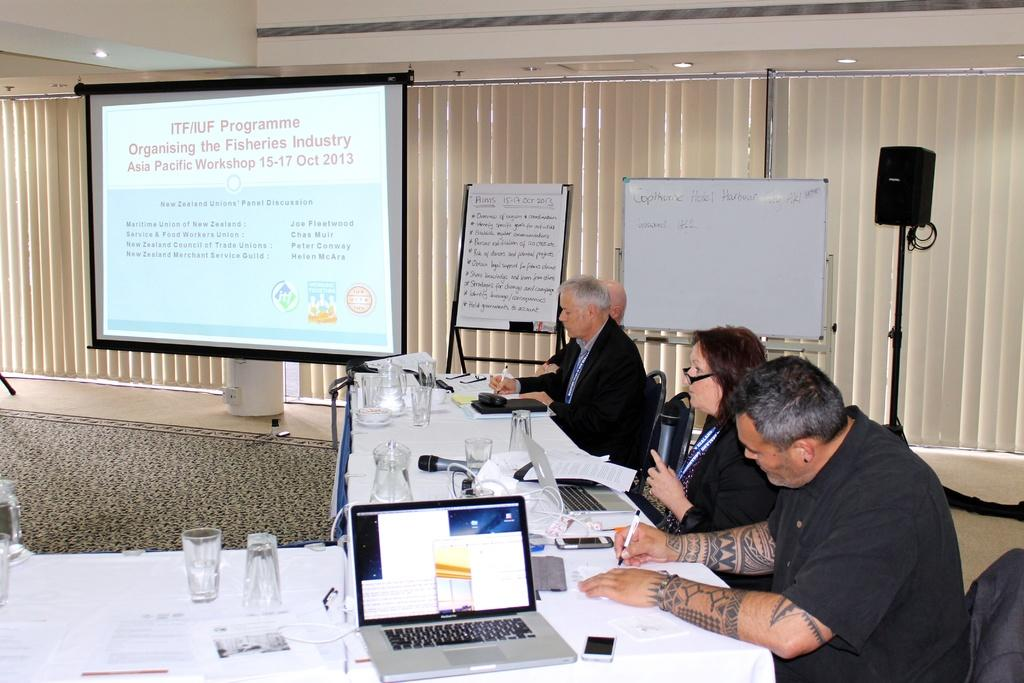<image>
Relay a brief, clear account of the picture shown. An October 2013 conference is underway on the subject of organizing the fisheries industry. 